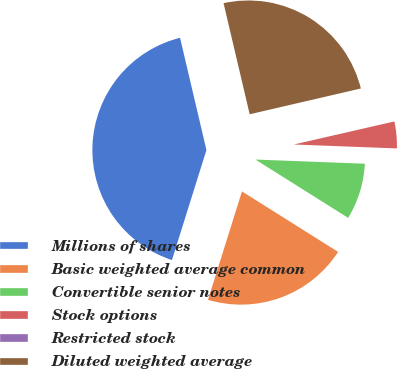Convert chart to OTSL. <chart><loc_0><loc_0><loc_500><loc_500><pie_chart><fcel>Millions of shares<fcel>Basic weighted average common<fcel>Convertible senior notes<fcel>Stock options<fcel>Restricted stock<fcel>Diluted weighted average<nl><fcel>41.49%<fcel>20.9%<fcel>8.33%<fcel>4.19%<fcel>0.04%<fcel>25.05%<nl></chart> 